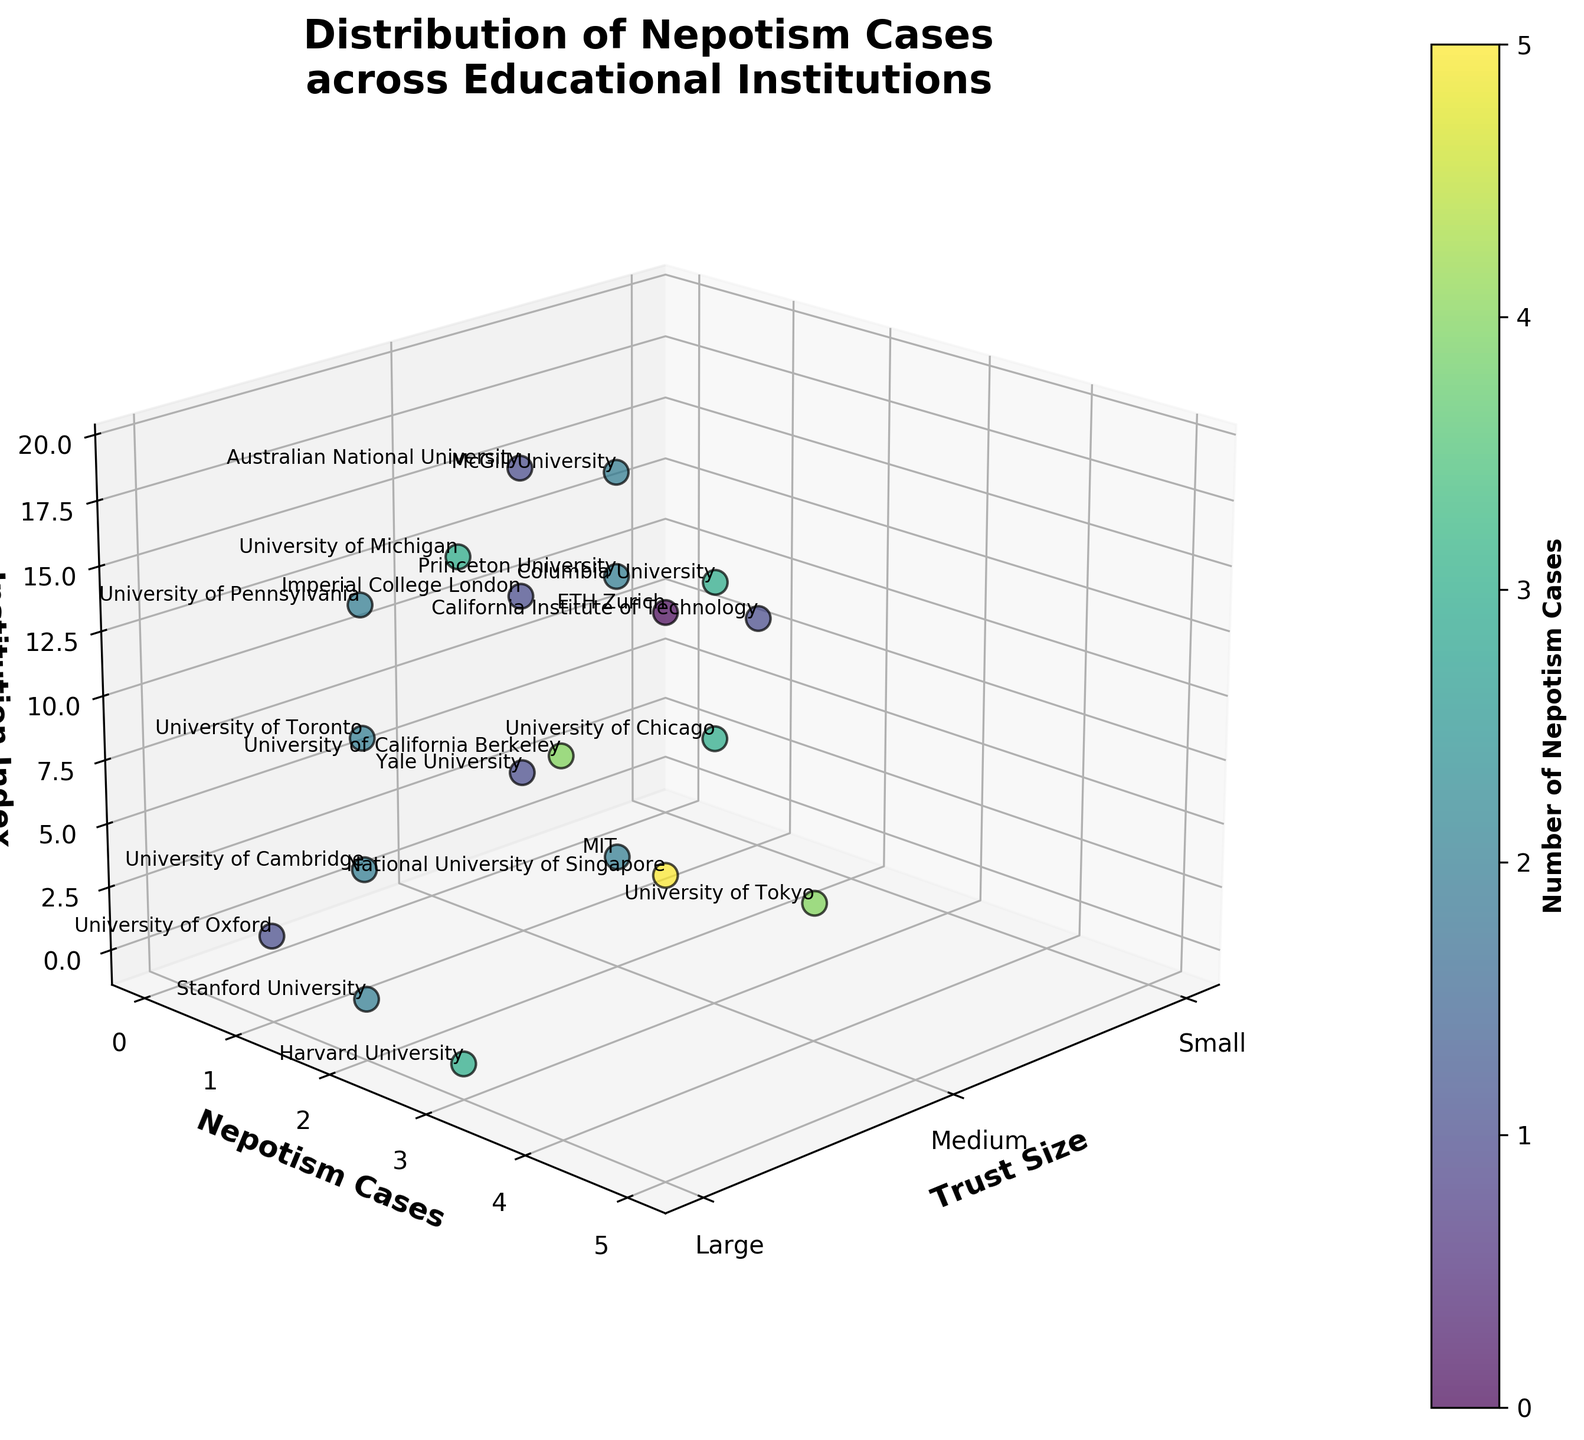What is the title of the 3D scatter plot? The title of the plot is displayed prominently at the top of the figure.
Answer: Distribution of Nepotism Cases across Educational Institutions Which educational institution has the highest number of nepotism cases? By looking at the plot and identifying the highest data point on the Nepotism Cases axis, we can determine that the National University of Singapore has the highest value.
Answer: National University of Singapore How many small trust institutions are present in the figure? By examining the Trust Size axis and counting the data points labeled as "Small," we can determine there are two such points.
Answer: 2 Compare the number of nepotism cases between Harvard University and University of Michigan. Locate Harvard University and University of Michigan on the plot and compare their positions along the Nepotism Cases axis. Harvard has 3 cases, and University of Michigan also has 3 cases.
Answer: Equal What is the geographical region with the most cases of nepotism? By analyzing the colors and noting the different geographical regions, it becomes evident that the Southeast Asia region has the highest value for nepotism cases.
Answer: Southeast Asia What is the average number of nepotism cases for institutions with medium trust size? Identify the institutions labeled as "Medium" on the Trust Size axis, sum their nepotism cases, and divide by the number of such institutions. (2+4+1+3+2+1+2)/7 = 15/7
Answer: 2.14 Which institution in the Northeast region has the highest number of nepotism cases? By looking at the column and comparing values for institutions in the Northeast, we find Columbia University having the highest value with 3 cases.
Answer: Columbia University How many institutions in the plot have zero nepotism cases? By examining the Nepotism Cases axis and identifying data points with a value of zero, we note there's one such institution.
Answer: 1 What's the median number of nepotism cases? To find the median, list all the nepotism cases in ascending order and find the middle value. The sequence is [0, 1, 1, 1, 1, 2, 2, 2, 2, 2, 3, 3, 3, 3, 4, 4, 5], so the median is 2
Answer: 2 